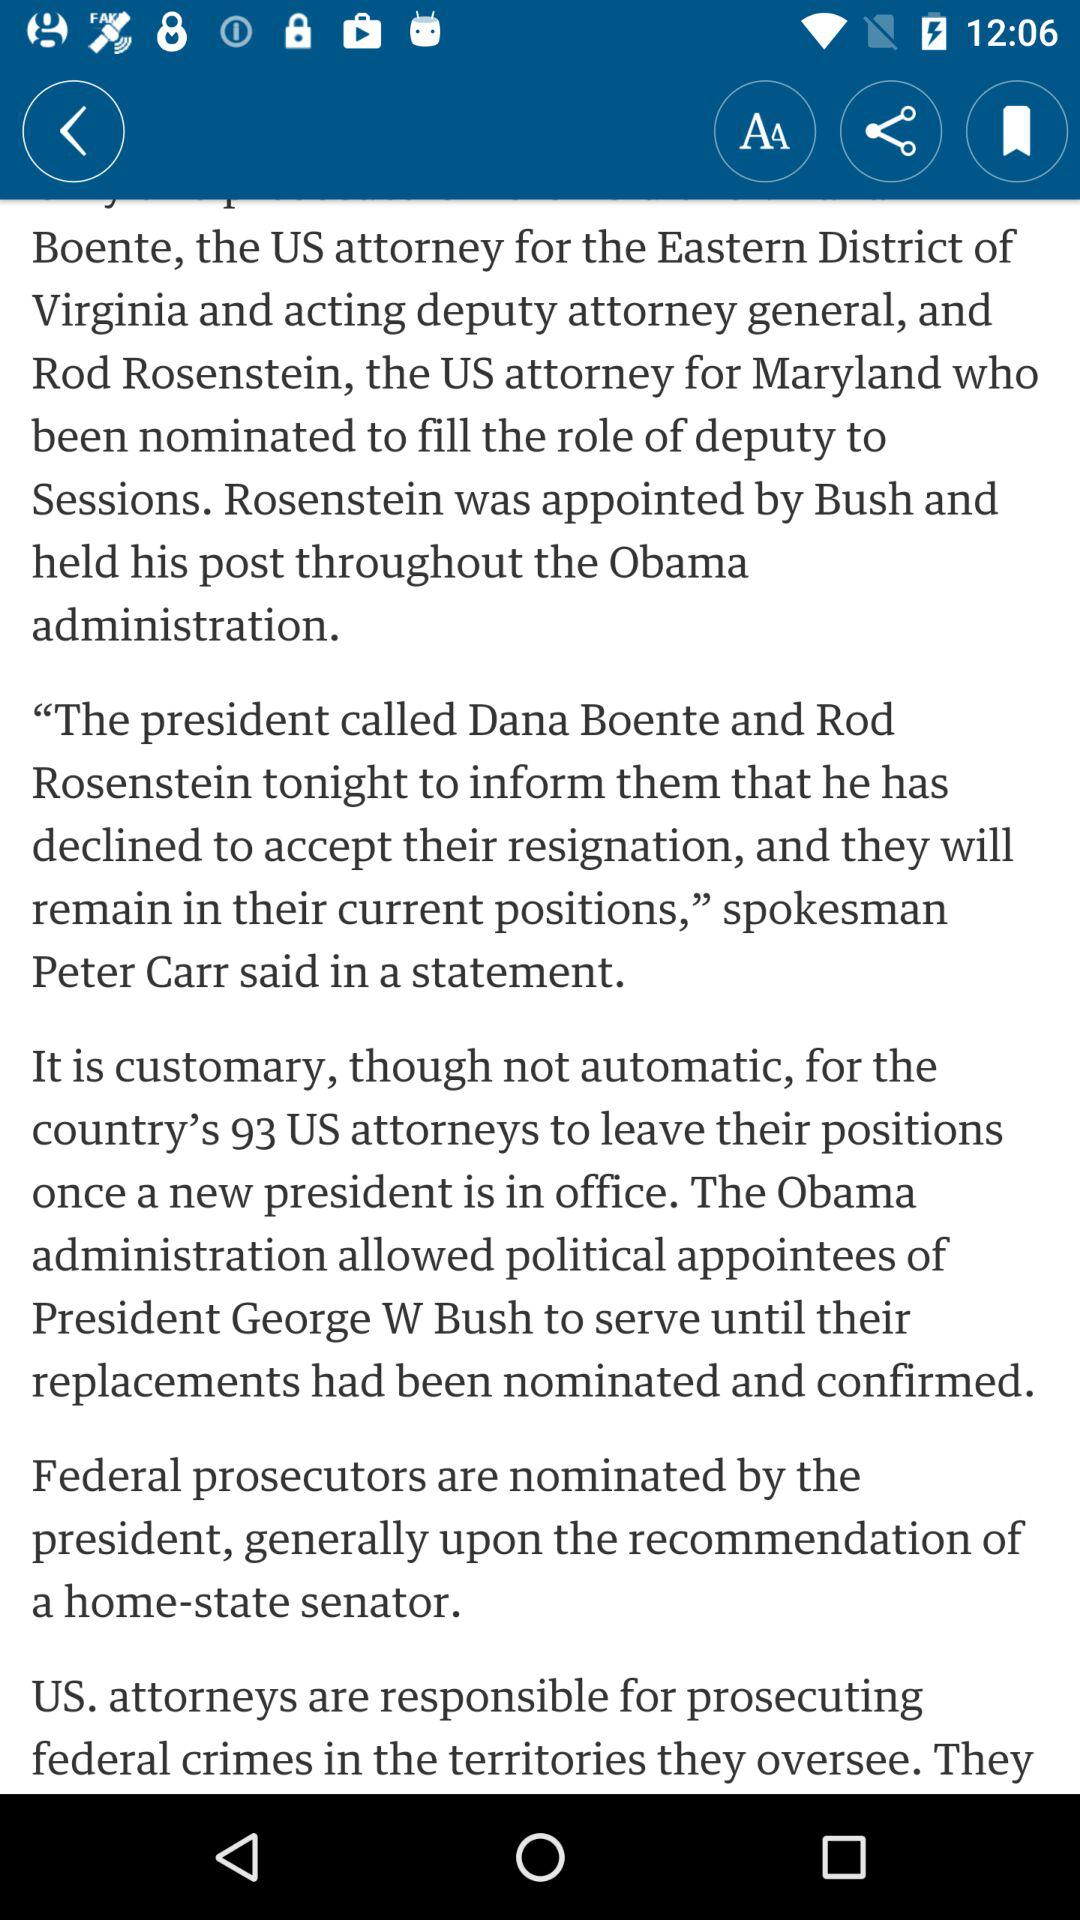Who will leave when the new president takes over the reins? When the new president takes over the reins, the 93rd US attorney will leave. 